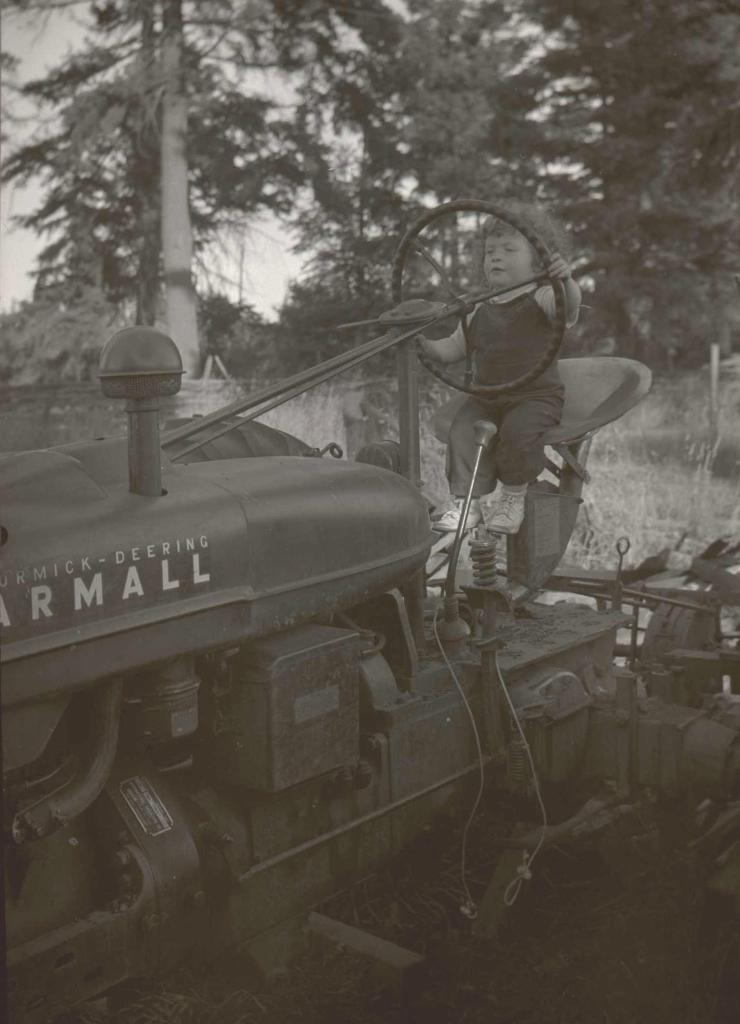What is the color scheme of the image? The image is black and white. What is the main subject of the image? There is a tractor in the image. Who is operating the tractor? A kid is sitting in front of the steering of the tractor. What can be seen in the background of the image? There are many trees behind the tractor. What type of vegetation is visible in the image? There is grass visible in the image. What type of cabbage is being harvested by the creature in the image? There is no creature or cabbage present in the image; it features a tractor with a kid operating it. What is the best way to reach the destination in the image? There is no destination or way to reach it mentioned in the image, as it only shows a tractor and a kid. 